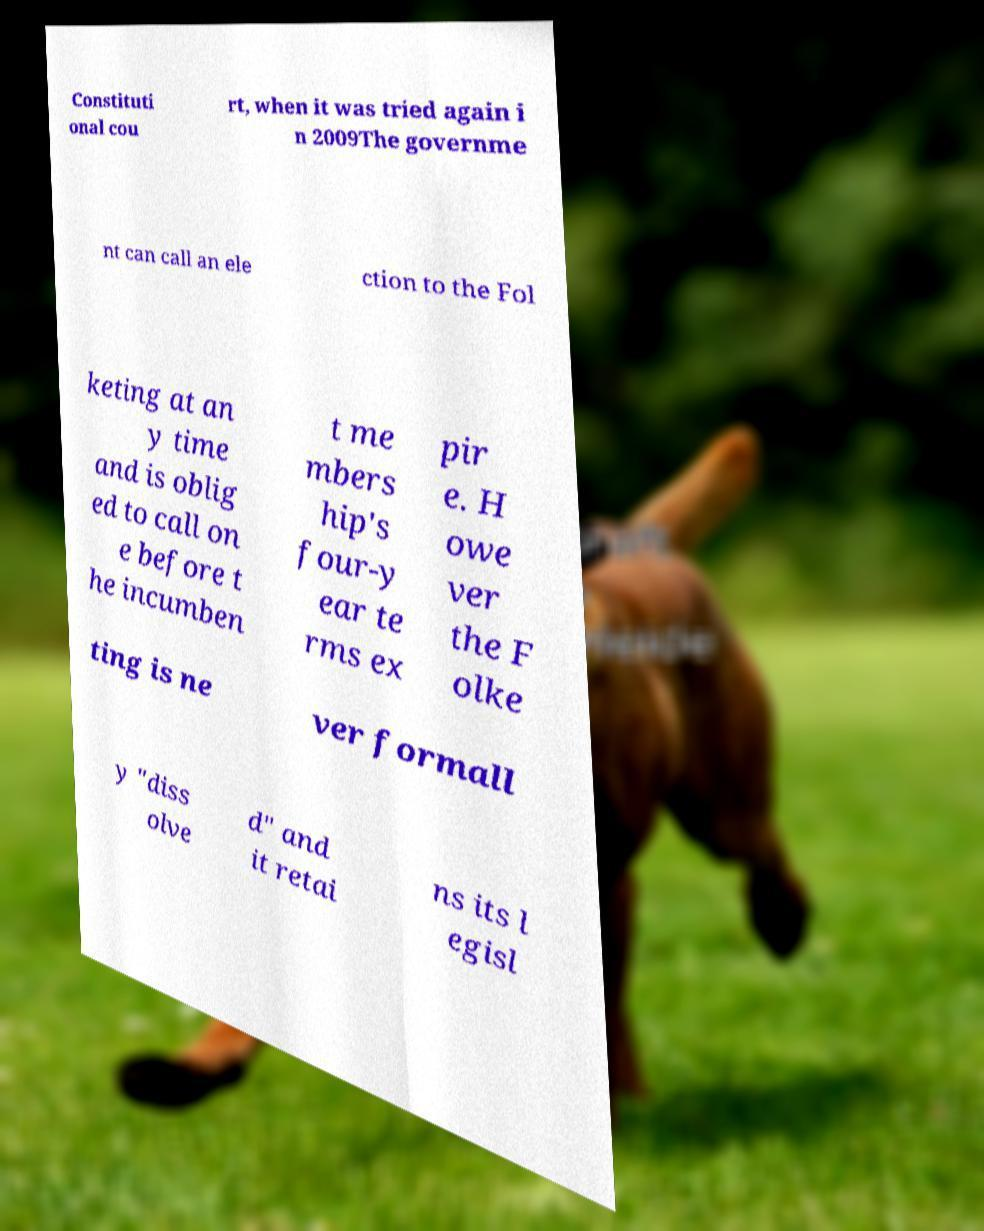Could you assist in decoding the text presented in this image and type it out clearly? Constituti onal cou rt, when it was tried again i n 2009The governme nt can call an ele ction to the Fol keting at an y time and is oblig ed to call on e before t he incumben t me mbers hip's four-y ear te rms ex pir e. H owe ver the F olke ting is ne ver formall y "diss olve d" and it retai ns its l egisl 